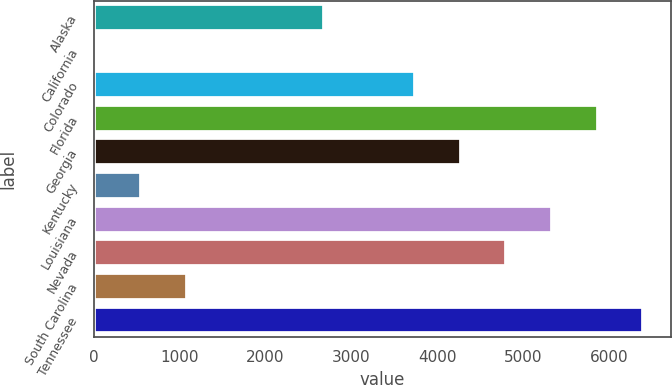Convert chart. <chart><loc_0><loc_0><loc_500><loc_500><bar_chart><fcel>Alaska<fcel>California<fcel>Colorado<fcel>Florida<fcel>Georgia<fcel>Kentucky<fcel>Louisiana<fcel>Nevada<fcel>South Carolina<fcel>Tennessee<nl><fcel>2679<fcel>22<fcel>3741.8<fcel>5867.4<fcel>4273.2<fcel>553.4<fcel>5336<fcel>4804.6<fcel>1084.8<fcel>6398.8<nl></chart> 